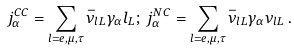<formula> <loc_0><loc_0><loc_500><loc_500>j ^ { C C } _ { \alpha } = \sum _ { l = e , \mu , \tau } \bar { \nu } _ { l L } \gamma _ { \alpha } l _ { L } ; \, j ^ { N C } _ { \alpha } = \sum _ { l = e , \mu , \tau } \bar { \nu } _ { l L } \gamma _ { \alpha } \nu _ { l L } \, .</formula> 